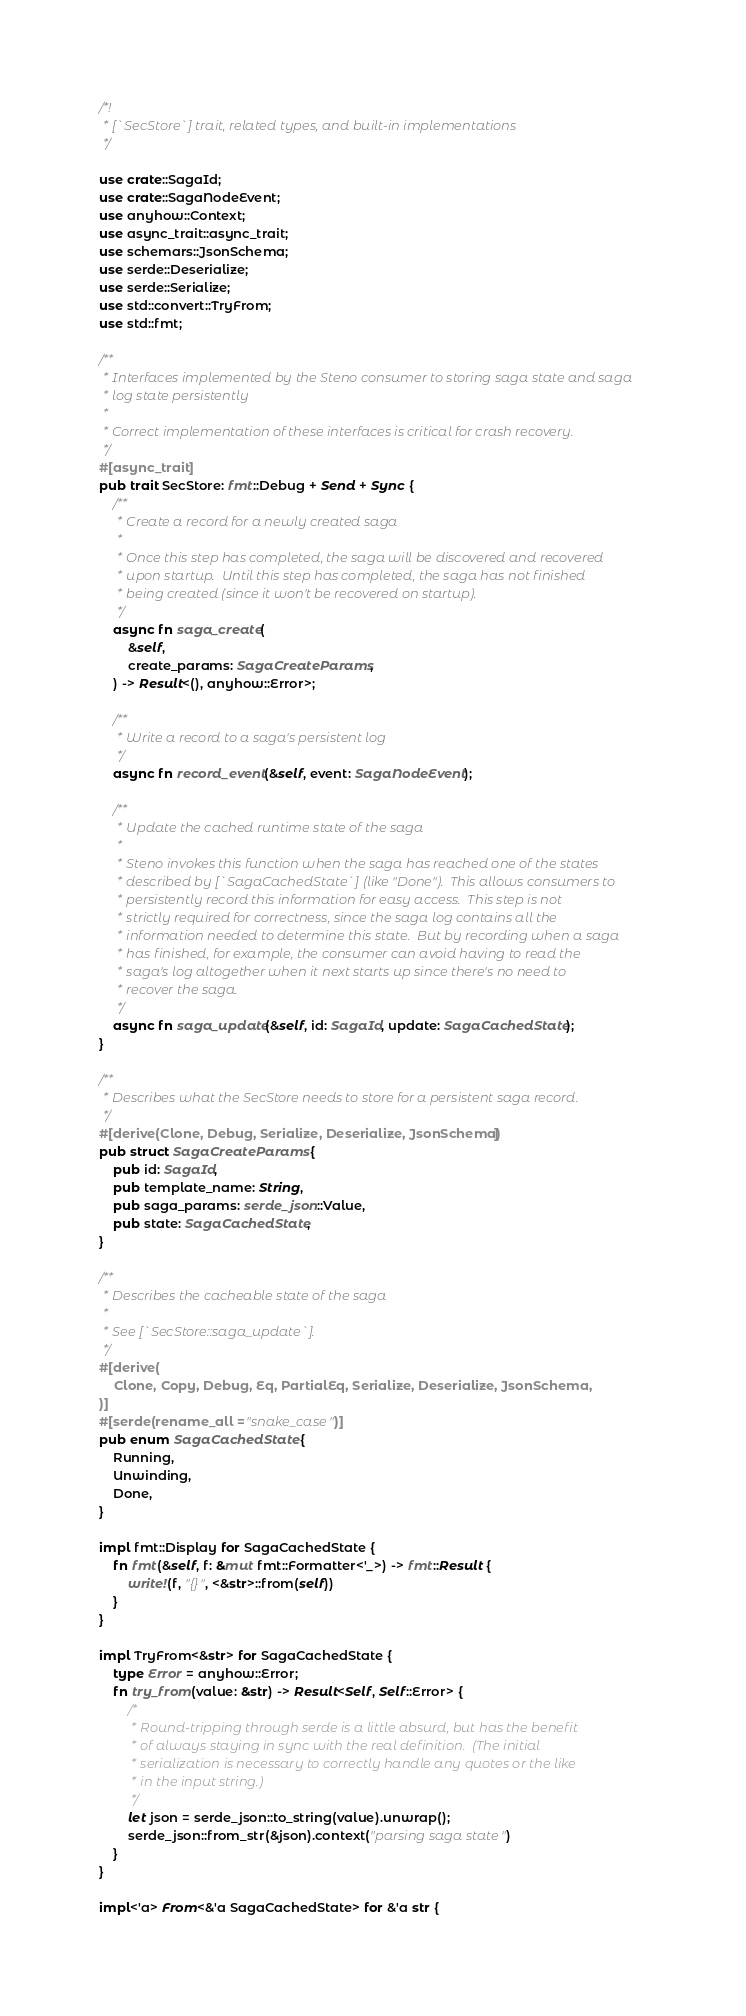Convert code to text. <code><loc_0><loc_0><loc_500><loc_500><_Rust_>/*!
 * [`SecStore`] trait, related types, and built-in implementations
 */

use crate::SagaId;
use crate::SagaNodeEvent;
use anyhow::Context;
use async_trait::async_trait;
use schemars::JsonSchema;
use serde::Deserialize;
use serde::Serialize;
use std::convert::TryFrom;
use std::fmt;

/**
 * Interfaces implemented by the Steno consumer to storing saga state and saga
 * log state persistently
 *
 * Correct implementation of these interfaces is critical for crash recovery.
 */
#[async_trait]
pub trait SecStore: fmt::Debug + Send + Sync {
    /**
     * Create a record for a newly created saga
     *
     * Once this step has completed, the saga will be discovered and recovered
     * upon startup.  Until this step has completed, the saga has not finished
     * being created (since it won't be recovered on startup).
     */
    async fn saga_create(
        &self,
        create_params: SagaCreateParams,
    ) -> Result<(), anyhow::Error>;

    /**
     * Write a record to a saga's persistent log
     */
    async fn record_event(&self, event: SagaNodeEvent);

    /**
     * Update the cached runtime state of the saga
     *
     * Steno invokes this function when the saga has reached one of the states
     * described by [`SagaCachedState`] (like "Done").  This allows consumers to
     * persistently record this information for easy access.  This step is not
     * strictly required for correctness, since the saga log contains all the
     * information needed to determine this state.  But by recording when a saga
     * has finished, for example, the consumer can avoid having to read the
     * saga's log altogether when it next starts up since there's no need to
     * recover the saga.
     */
    async fn saga_update(&self, id: SagaId, update: SagaCachedState);
}

/**
 * Describes what the SecStore needs to store for a persistent saga record.
 */
#[derive(Clone, Debug, Serialize, Deserialize, JsonSchema)]
pub struct SagaCreateParams {
    pub id: SagaId,
    pub template_name: String,
    pub saga_params: serde_json::Value,
    pub state: SagaCachedState,
}

/**
 * Describes the cacheable state of the saga
 *
 * See [`SecStore::saga_update`].
 */
#[derive(
    Clone, Copy, Debug, Eq, PartialEq, Serialize, Deserialize, JsonSchema,
)]
#[serde(rename_all = "snake_case")]
pub enum SagaCachedState {
    Running,
    Unwinding,
    Done,
}

impl fmt::Display for SagaCachedState {
    fn fmt(&self, f: &mut fmt::Formatter<'_>) -> fmt::Result {
        write!(f, "{}", <&str>::from(self))
    }
}

impl TryFrom<&str> for SagaCachedState {
    type Error = anyhow::Error;
    fn try_from(value: &str) -> Result<Self, Self::Error> {
        /*
         * Round-tripping through serde is a little absurd, but has the benefit
         * of always staying in sync with the real definition.  (The initial
         * serialization is necessary to correctly handle any quotes or the like
         * in the input string.)
         */
        let json = serde_json::to_string(value).unwrap();
        serde_json::from_str(&json).context("parsing saga state")
    }
}

impl<'a> From<&'a SagaCachedState> for &'a str {</code> 